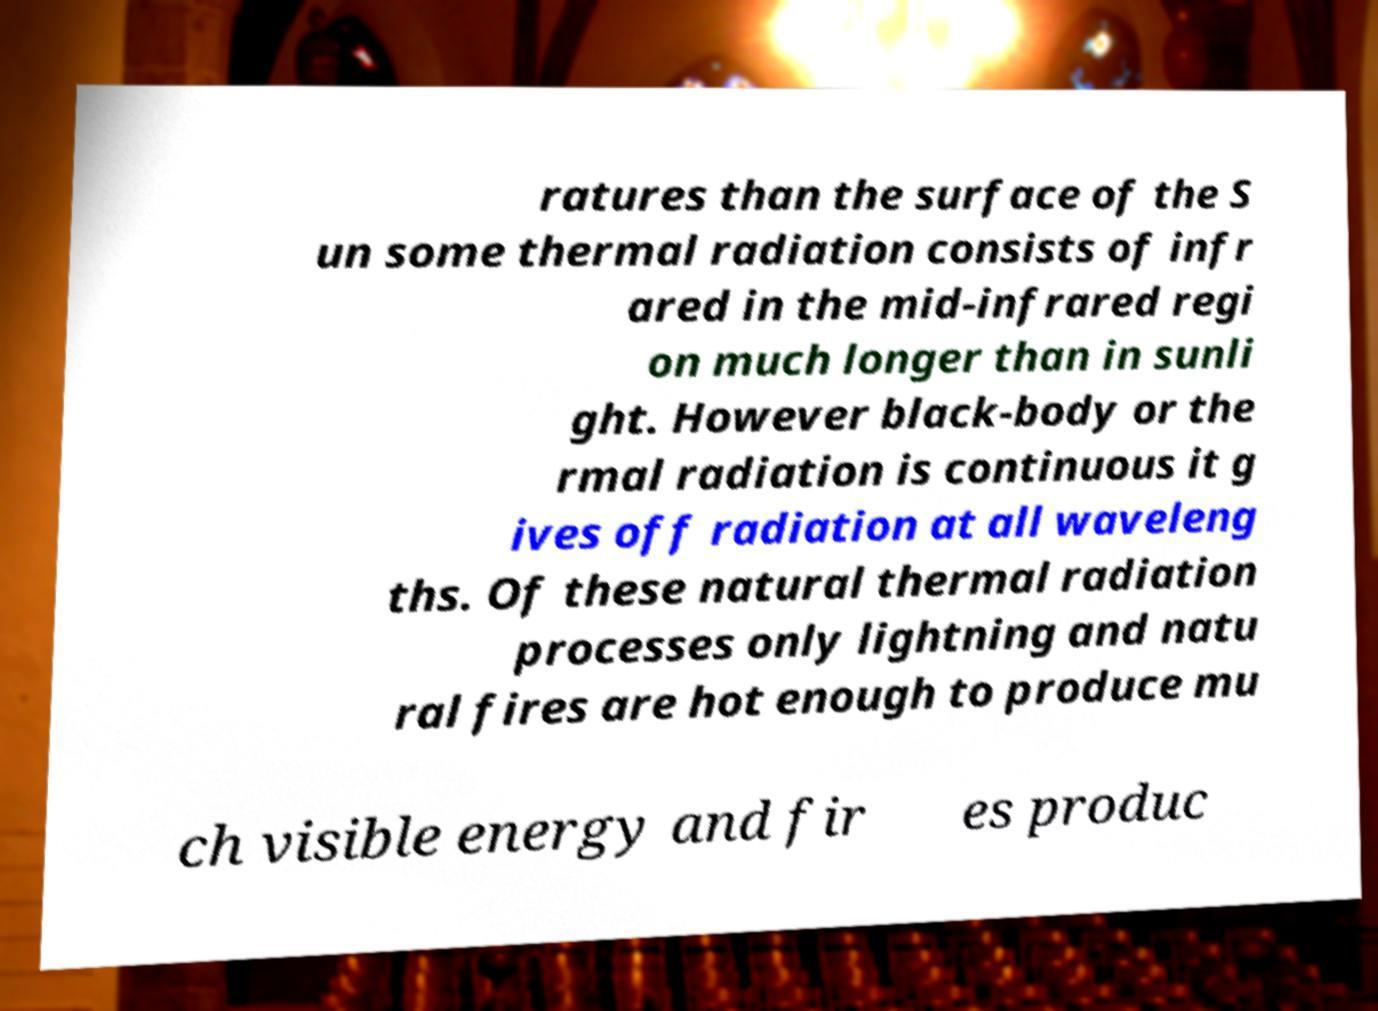Please identify and transcribe the text found in this image. ratures than the surface of the S un some thermal radiation consists of infr ared in the mid-infrared regi on much longer than in sunli ght. However black-body or the rmal radiation is continuous it g ives off radiation at all waveleng ths. Of these natural thermal radiation processes only lightning and natu ral fires are hot enough to produce mu ch visible energy and fir es produc 